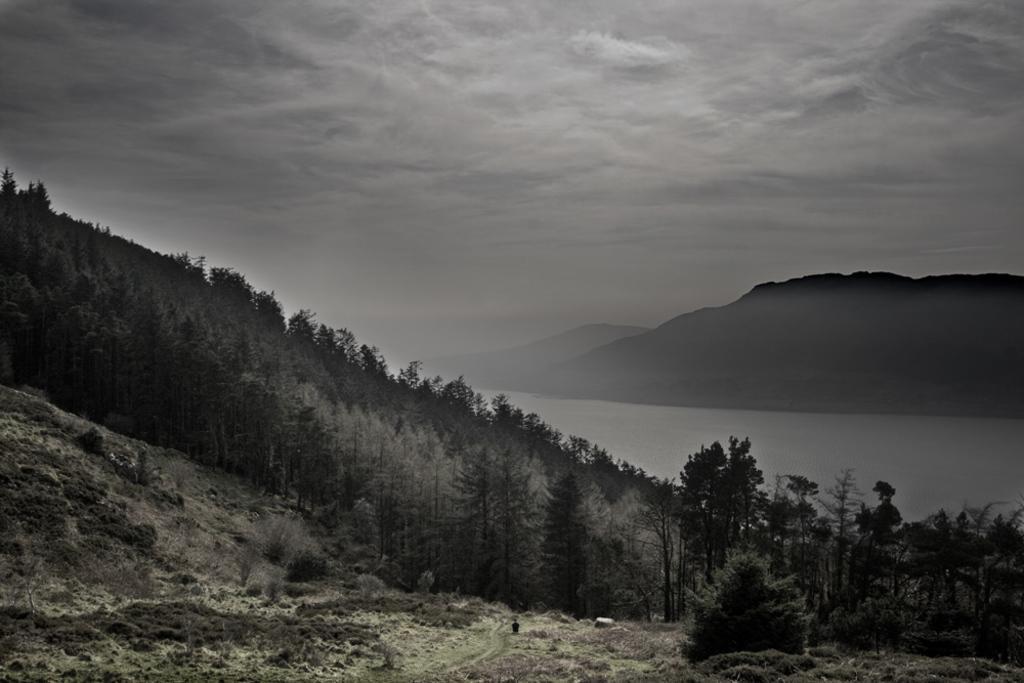How would you summarize this image in a sentence or two? This is a black and white picture, there are many trees and plants on the hill in the front, in front of it there is a lake followed by mountains behind it and above its sky with clouds. 